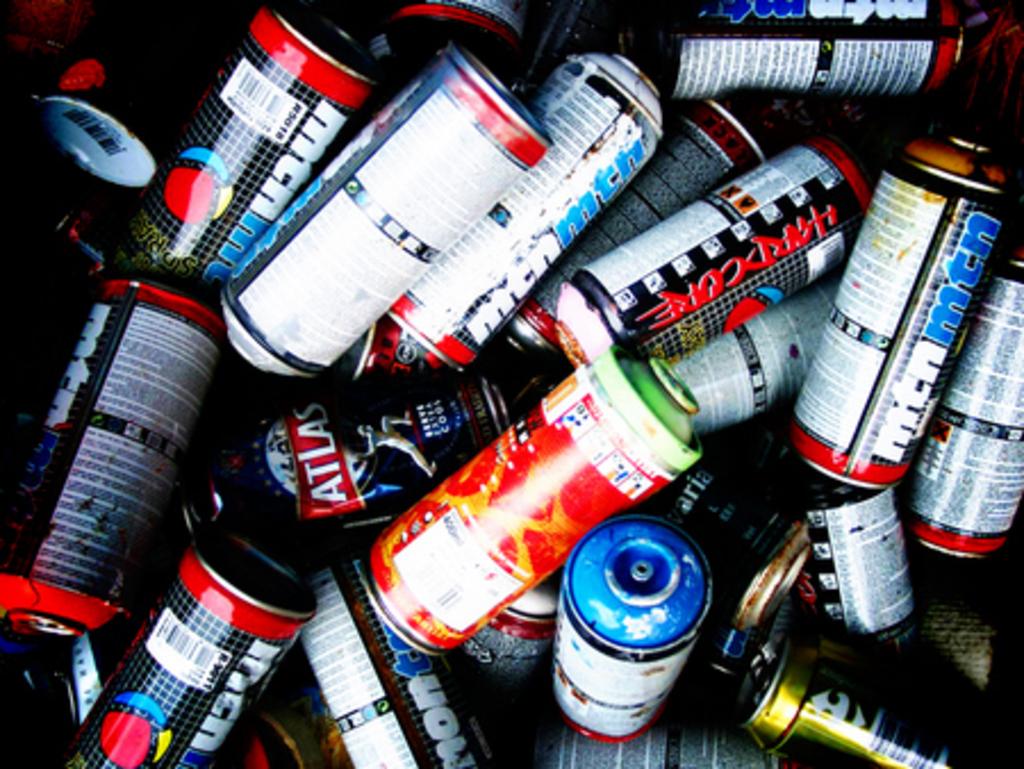What is the brand of can most frequent in this?
Ensure brevity in your answer.  Mtn. 